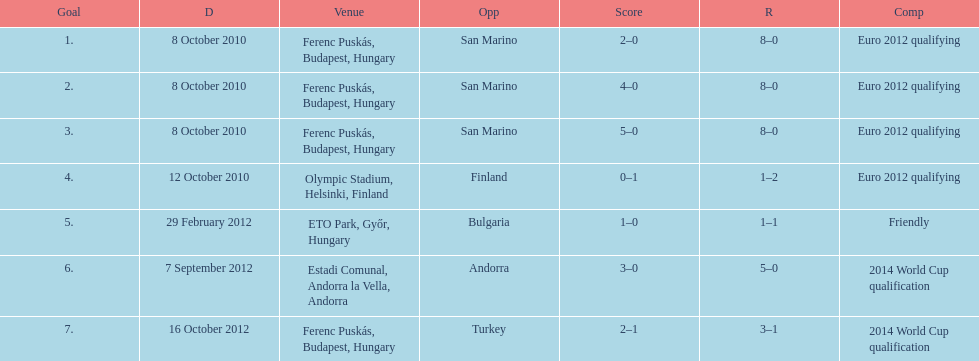In what year did ádám szalai make his next international goal after 2010? 2012. 